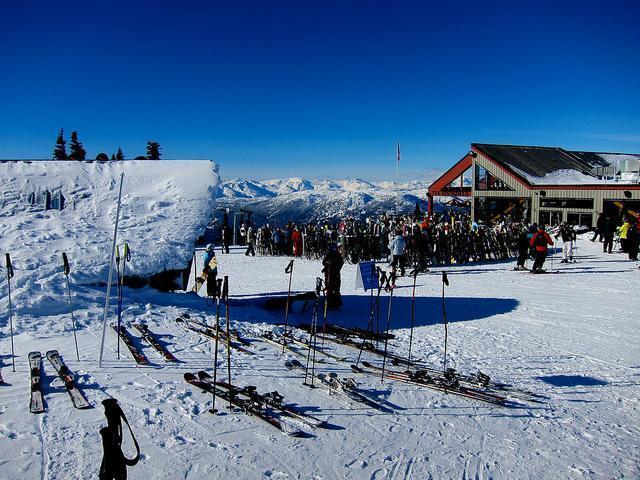How many people are there?
Give a very brief answer. 1. 